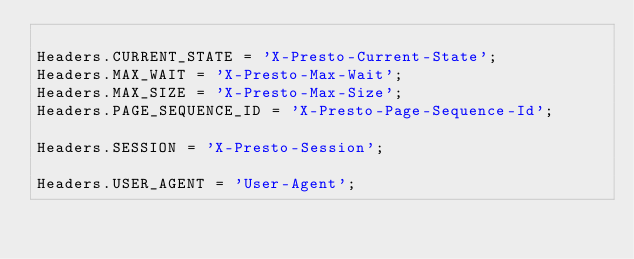Convert code to text. <code><loc_0><loc_0><loc_500><loc_500><_JavaScript_>
Headers.CURRENT_STATE = 'X-Presto-Current-State';
Headers.MAX_WAIT = 'X-Presto-Max-Wait';
Headers.MAX_SIZE = 'X-Presto-Max-Size';
Headers.PAGE_SEQUENCE_ID = 'X-Presto-Page-Sequence-Id';

Headers.SESSION = 'X-Presto-Session';

Headers.USER_AGENT = 'User-Agent';
</code> 